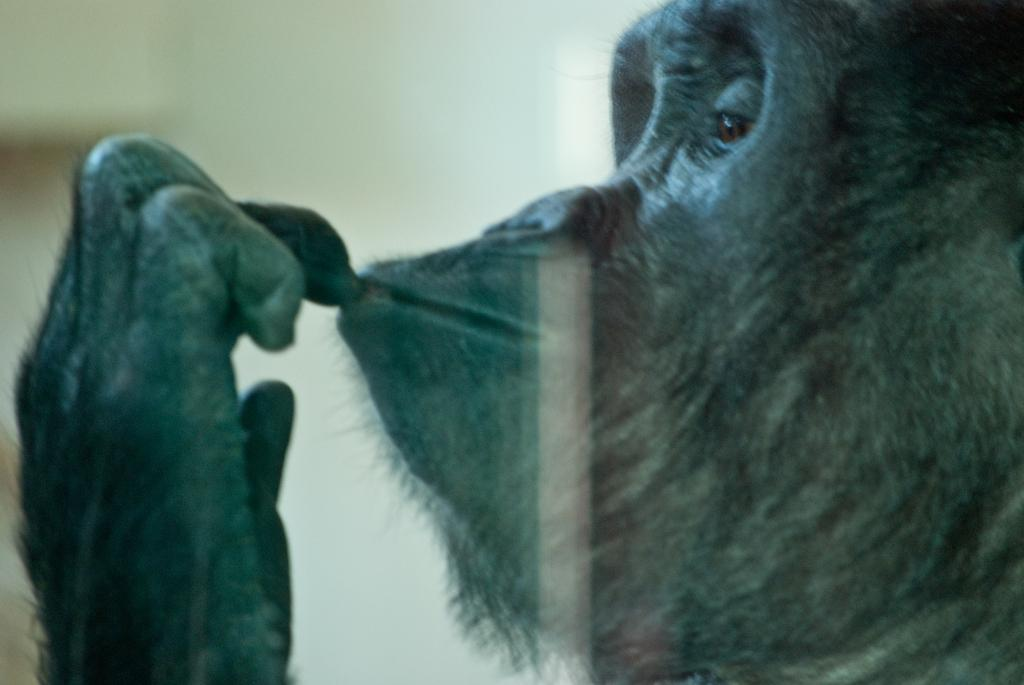What animal is present in the image? There is a gorilla in the image. Can you describe the setting or environment in the image? There may be a window in the image, which could suggest an indoor or outdoor setting. What color is the rose that the robin is holding in the image? There is no rose or robin present in the image; it features a gorilla. 